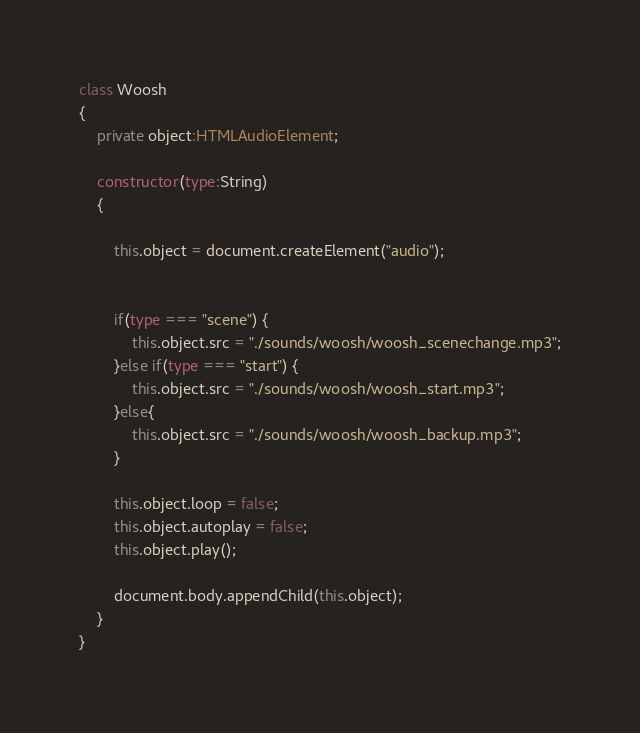<code> <loc_0><loc_0><loc_500><loc_500><_TypeScript_>class Woosh
{
    private object:HTMLAudioElement;

    constructor(type:String)
    {
        
        this.object = document.createElement("audio");


        if(type === "scene") {
            this.object.src = "./sounds/woosh/woosh_scenechange.mp3";
        }else if(type === "start") {
            this.object.src = "./sounds/woosh/woosh_start.mp3";
        }else{
            this.object.src = "./sounds/woosh/woosh_backup.mp3";
        }

        this.object.loop = false;
        this.object.autoplay = false;
        this.object.play();
        
        document.body.appendChild(this.object);
    }
}</code> 